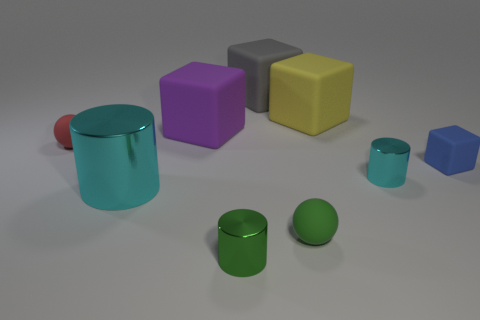There is a big object in front of the cyan object that is to the right of the gray rubber object; what is its shape?
Your response must be concise. Cylinder. Are there any other things that are the same shape as the tiny cyan metallic thing?
Offer a terse response. Yes. Is the number of tiny cylinders left of the purple rubber thing greater than the number of rubber spheres?
Your answer should be very brief. No. What number of small blue matte things are right of the cyan cylinder right of the small green metallic cylinder?
Keep it short and to the point. 1. What is the shape of the large object in front of the ball left of the cyan metallic object that is to the left of the green sphere?
Make the answer very short. Cylinder. The red matte object is what size?
Provide a short and direct response. Small. Is there a cyan cube made of the same material as the red thing?
Offer a terse response. No. What is the size of the purple matte thing that is the same shape as the tiny blue matte object?
Provide a short and direct response. Large. Is the number of green spheres behind the tiny matte cube the same as the number of blue objects?
Provide a short and direct response. No. Do the metallic object that is on the left side of the large purple block and the yellow rubber thing have the same shape?
Offer a very short reply. No. 